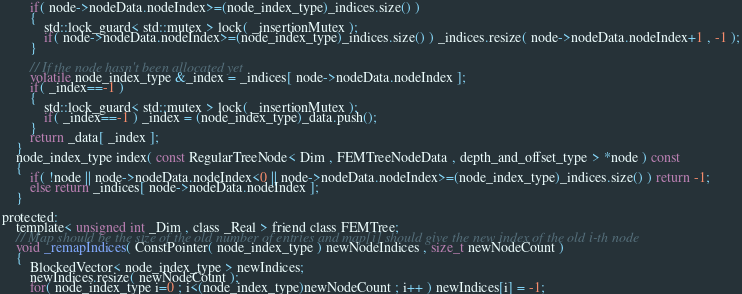Convert code to text. <code><loc_0><loc_0><loc_500><loc_500><_C_>		if( node->nodeData.nodeIndex>=(node_index_type)_indices.size() )
		{
			std::lock_guard< std::mutex > lock( _insertionMutex );
			if( node->nodeData.nodeIndex>=(node_index_type)_indices.size() ) _indices.resize( node->nodeData.nodeIndex+1 , -1 );
		}

		// If the node hasn't been allocated yet
		volatile node_index_type &_index = _indices[ node->nodeData.nodeIndex ];
		if( _index==-1 )
		{
			std::lock_guard< std::mutex > lock( _insertionMutex );
			if( _index==-1 ) _index = (node_index_type)_data.push();
		}
		return _data[ _index ];
	}
	node_index_type index( const RegularTreeNode< Dim , FEMTreeNodeData , depth_and_offset_type > *node ) const
	{
		if( !node || node->nodeData.nodeIndex<0 || node->nodeData.nodeIndex>=(node_index_type)_indices.size() ) return -1;
		else return _indices[ node->nodeData.nodeIndex ];
	}

protected:
	template< unsigned int _Dim , class _Real > friend class FEMTree;
	// Map should be the size of the old number of entries and map[i] should give the new index of the old i-th node
	void _remapIndices( ConstPointer( node_index_type ) newNodeIndices , size_t newNodeCount )
	{
		BlockedVector< node_index_type > newIndices;
		newIndices.resize( newNodeCount );
		for( node_index_type i=0 ; i<(node_index_type)newNodeCount ; i++ ) newIndices[i] = -1;</code> 